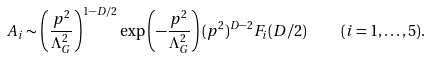<formula> <loc_0><loc_0><loc_500><loc_500>A _ { i } \sim \left ( \frac { p ^ { 2 } } { \Lambda _ { G } ^ { 2 } } \right ) ^ { 1 - D / 2 } \exp \left ( - \frac { p ^ { 2 } } { \Lambda _ { G } ^ { 2 } } \right ) ( p ^ { 2 } ) ^ { D - 2 } F _ { i } ( D / 2 ) \quad ( i = 1 , \dots , 5 ) .</formula> 